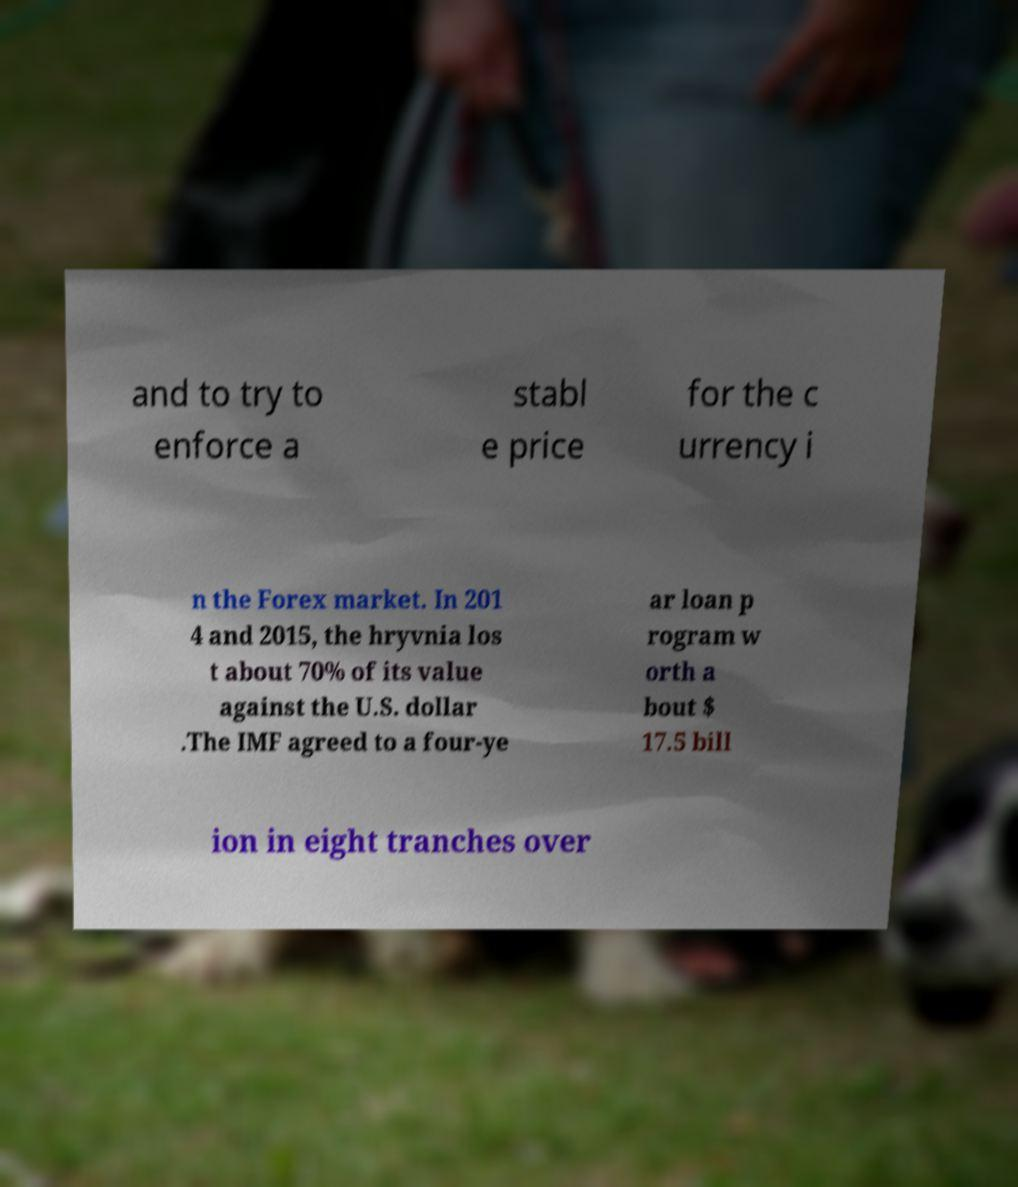Please read and relay the text visible in this image. What does it say? and to try to enforce a stabl e price for the c urrency i n the Forex market. In 201 4 and 2015, the hryvnia los t about 70% of its value against the U.S. dollar .The IMF agreed to a four-ye ar loan p rogram w orth a bout $ 17.5 bill ion in eight tranches over 